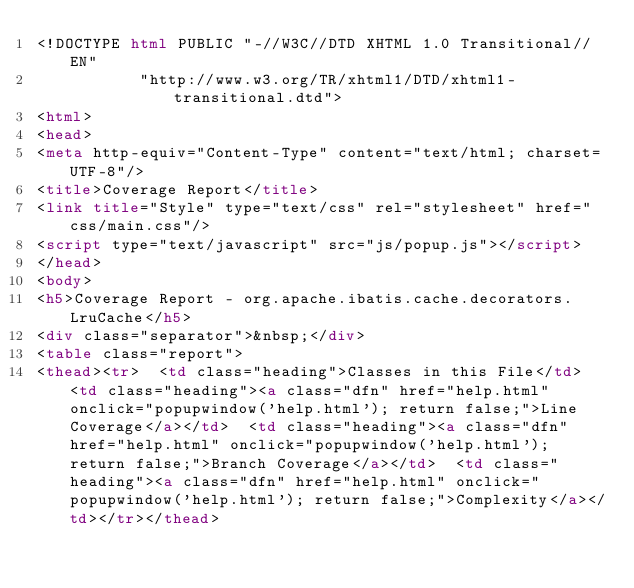Convert code to text. <code><loc_0><loc_0><loc_500><loc_500><_HTML_><!DOCTYPE html PUBLIC "-//W3C//DTD XHTML 1.0 Transitional//EN"
           "http://www.w3.org/TR/xhtml1/DTD/xhtml1-transitional.dtd">
<html>
<head>
<meta http-equiv="Content-Type" content="text/html; charset=UTF-8"/>
<title>Coverage Report</title>
<link title="Style" type="text/css" rel="stylesheet" href="css/main.css"/>
<script type="text/javascript" src="js/popup.js"></script>
</head>
<body>
<h5>Coverage Report - org.apache.ibatis.cache.decorators.LruCache</h5>
<div class="separator">&nbsp;</div>
<table class="report">
<thead><tr>  <td class="heading">Classes in this File</td>  <td class="heading"><a class="dfn" href="help.html" onclick="popupwindow('help.html'); return false;">Line Coverage</a></td>  <td class="heading"><a class="dfn" href="help.html" onclick="popupwindow('help.html'); return false;">Branch Coverage</a></td>  <td class="heading"><a class="dfn" href="help.html" onclick="popupwindow('help.html'); return false;">Complexity</a></td></tr></thead></code> 